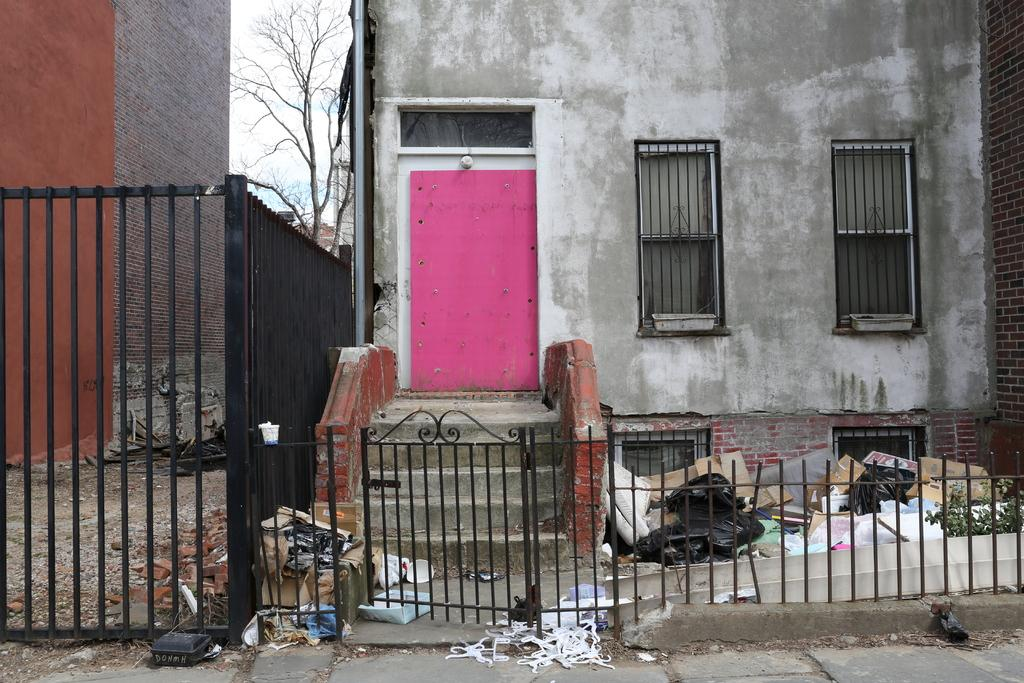What type of structures are present in the image? There are buildings in the image. What features can be seen on the buildings? The buildings have windows, stairs, and doors. What type of vegetation is present in the image? There are dry trees in the image. What architectural elements can be seen in the image? There is a railing and a gate in the image. What is on the road in the image? There are objects on the road in the image. What is the color of the sky in the image? The sky is blue and white in color. What type of news can be heard coming from the buildings in the image? There is no indication in the image that any news is being broadcast or discussed in the buildings. 